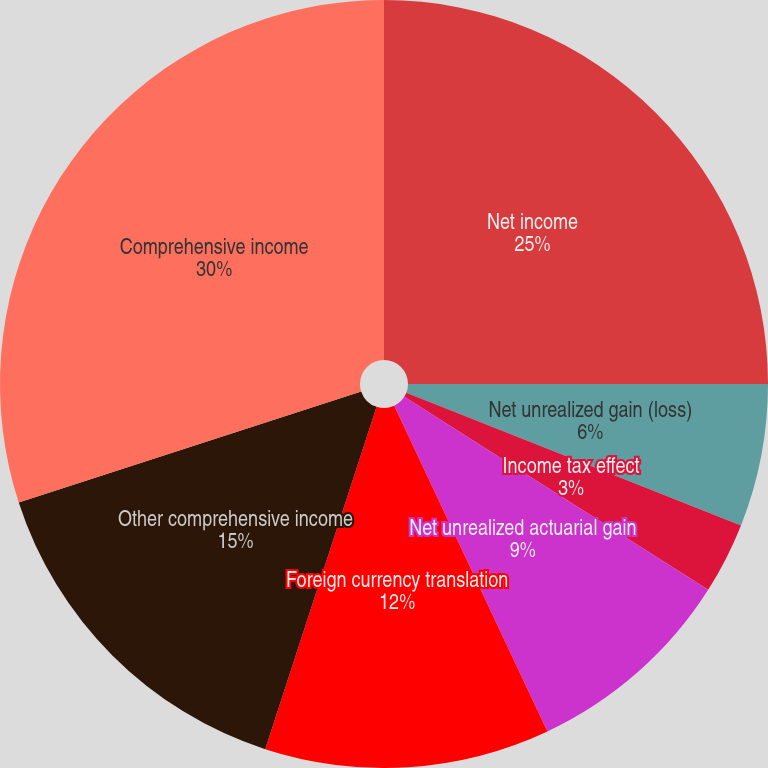<chart> <loc_0><loc_0><loc_500><loc_500><pie_chart><fcel>Net income<fcel>Net unrealized gain (loss)<fcel>Income tax effect<fcel>Reclassification adjustments<fcel>Net unrealized actuarial gain<fcel>Foreign currency translation<fcel>Other comprehensive income<fcel>Comprehensive income<nl><fcel>25.0%<fcel>6.0%<fcel>3.0%<fcel>0.0%<fcel>9.0%<fcel>12.0%<fcel>15.0%<fcel>29.99%<nl></chart> 